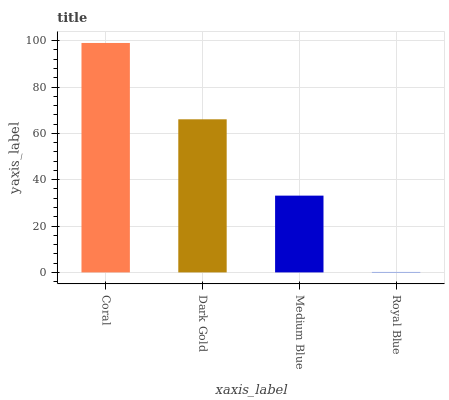Is Dark Gold the minimum?
Answer yes or no. No. Is Dark Gold the maximum?
Answer yes or no. No. Is Coral greater than Dark Gold?
Answer yes or no. Yes. Is Dark Gold less than Coral?
Answer yes or no. Yes. Is Dark Gold greater than Coral?
Answer yes or no. No. Is Coral less than Dark Gold?
Answer yes or no. No. Is Dark Gold the high median?
Answer yes or no. Yes. Is Medium Blue the low median?
Answer yes or no. Yes. Is Medium Blue the high median?
Answer yes or no. No. Is Royal Blue the low median?
Answer yes or no. No. 